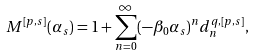Convert formula to latex. <formula><loc_0><loc_0><loc_500><loc_500>M ^ { [ p , s ] } ( \alpha _ { s } ) = 1 + \sum _ { n = 0 } ^ { \infty } ( - \beta _ { 0 } \alpha _ { s } ) ^ { n } d _ { n } ^ { q , [ p , s ] } ,</formula> 